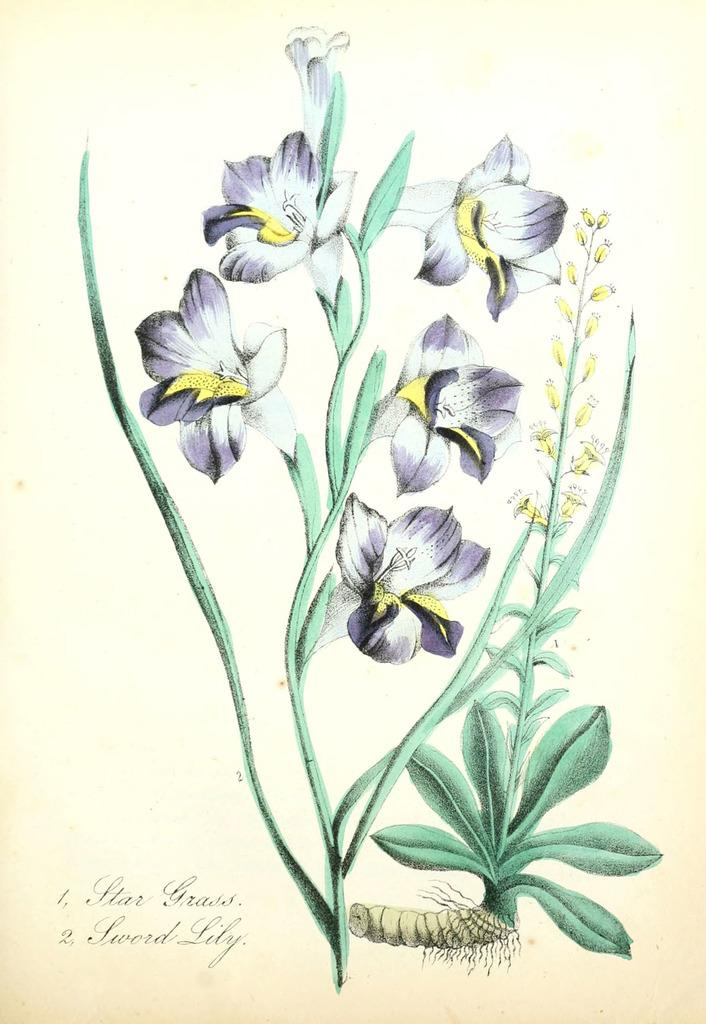What is depicted in the painting in the image? There is a painting of a plant in the image, which includes flowers. What is the background of the painting? The painting is on a white paper. Is there any text associated with the painting? Yes, there is text at the bottom of the image. What type of can is shown in the painting? There is no can present in the painting; it depicts a plant with flowers. What time does the clock in the painting show? There is no clock present in the painting; it features a plant with flowers. 